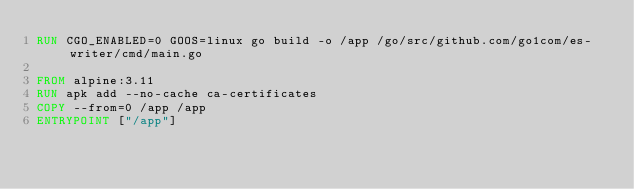Convert code to text. <code><loc_0><loc_0><loc_500><loc_500><_Dockerfile_>RUN CGO_ENABLED=0 GOOS=linux go build -o /app /go/src/github.com/go1com/es-writer/cmd/main.go

FROM alpine:3.11
RUN apk add --no-cache ca-certificates
COPY --from=0 /app /app
ENTRYPOINT ["/app"]
</code> 